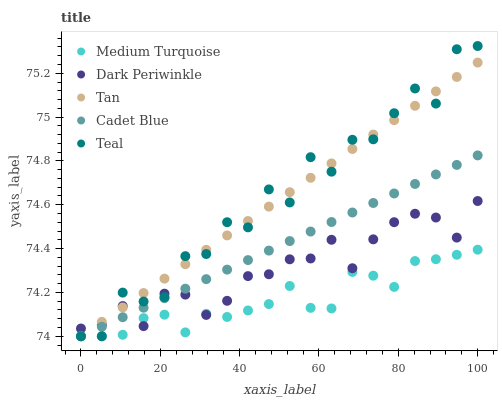Does Medium Turquoise have the minimum area under the curve?
Answer yes or no. Yes. Does Teal have the maximum area under the curve?
Answer yes or no. Yes. Does Tan have the minimum area under the curve?
Answer yes or no. No. Does Tan have the maximum area under the curve?
Answer yes or no. No. Is Tan the smoothest?
Answer yes or no. Yes. Is Teal the roughest?
Answer yes or no. Yes. Is Cadet Blue the smoothest?
Answer yes or no. No. Is Cadet Blue the roughest?
Answer yes or no. No. Does Teal have the lowest value?
Answer yes or no. Yes. Does Dark Periwinkle have the lowest value?
Answer yes or no. No. Does Teal have the highest value?
Answer yes or no. Yes. Does Tan have the highest value?
Answer yes or no. No. Does Medium Turquoise intersect Teal?
Answer yes or no. Yes. Is Medium Turquoise less than Teal?
Answer yes or no. No. Is Medium Turquoise greater than Teal?
Answer yes or no. No. 